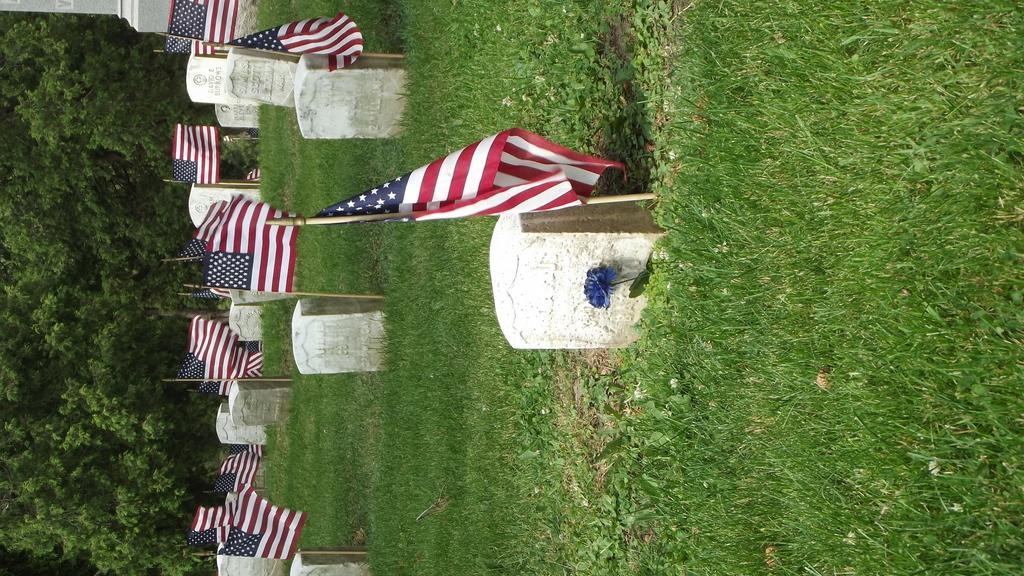What is the main subject in the center of the image? There are gravestones and flags in the center of the image. What type of vegetation is present in the center of the image? There is grass in the center of the image. What can be seen on the left side of the image? There are trees on the left side of the image. What type of vegetation is present on the right side of the image? There is grass on the right side of the image. How many vests are hanging on the trees in the image? There are no vests present in the image; it features gravestones, flags, and trees. What type of pies can be seen on the gravestones in the image? There are no pies present on the gravestones in the image; it features gravestones, flags, and trees. 